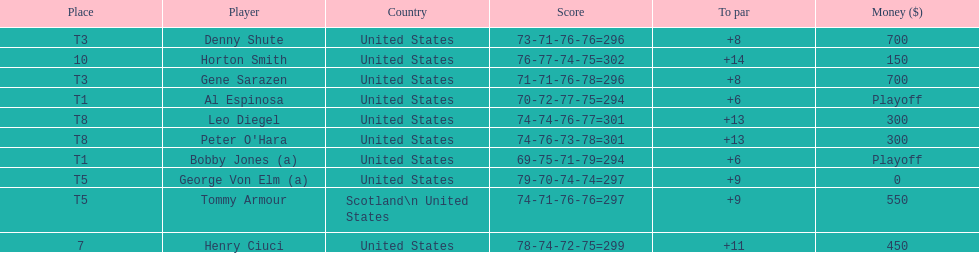Who was the last player in the top 10? Horton Smith. 